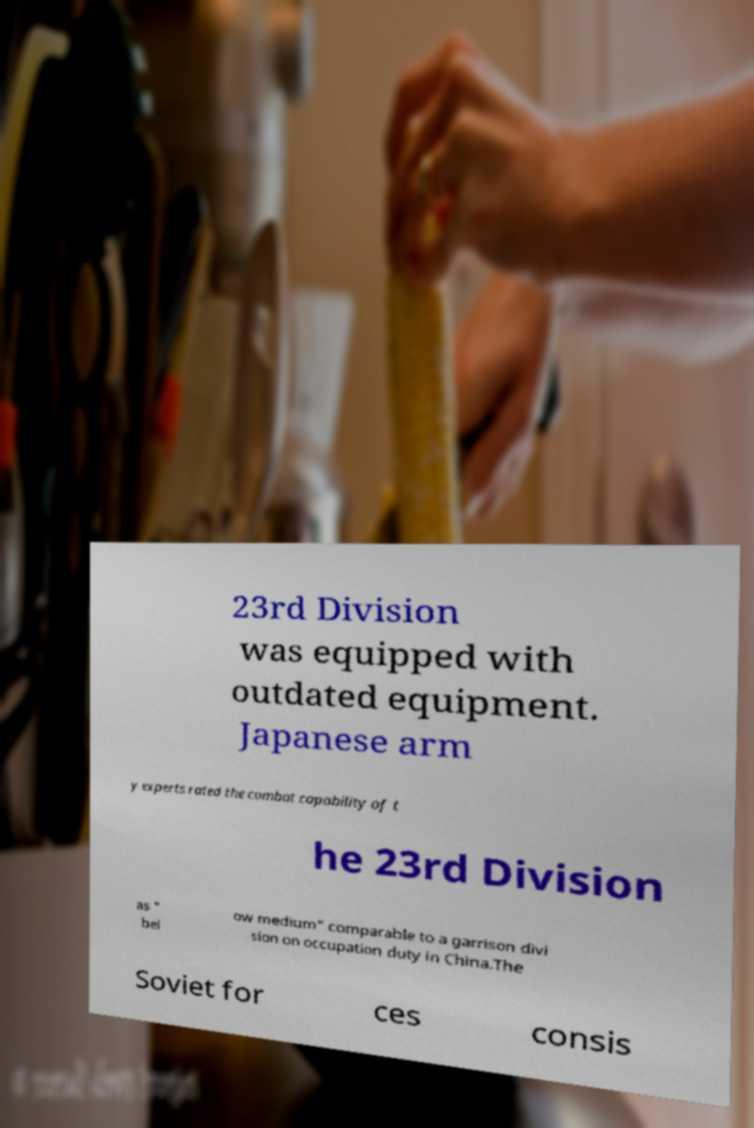Could you extract and type out the text from this image? 23rd Division was equipped with outdated equipment. Japanese arm y experts rated the combat capability of t he 23rd Division as " bel ow medium" comparable to a garrison divi sion on occupation duty in China.The Soviet for ces consis 